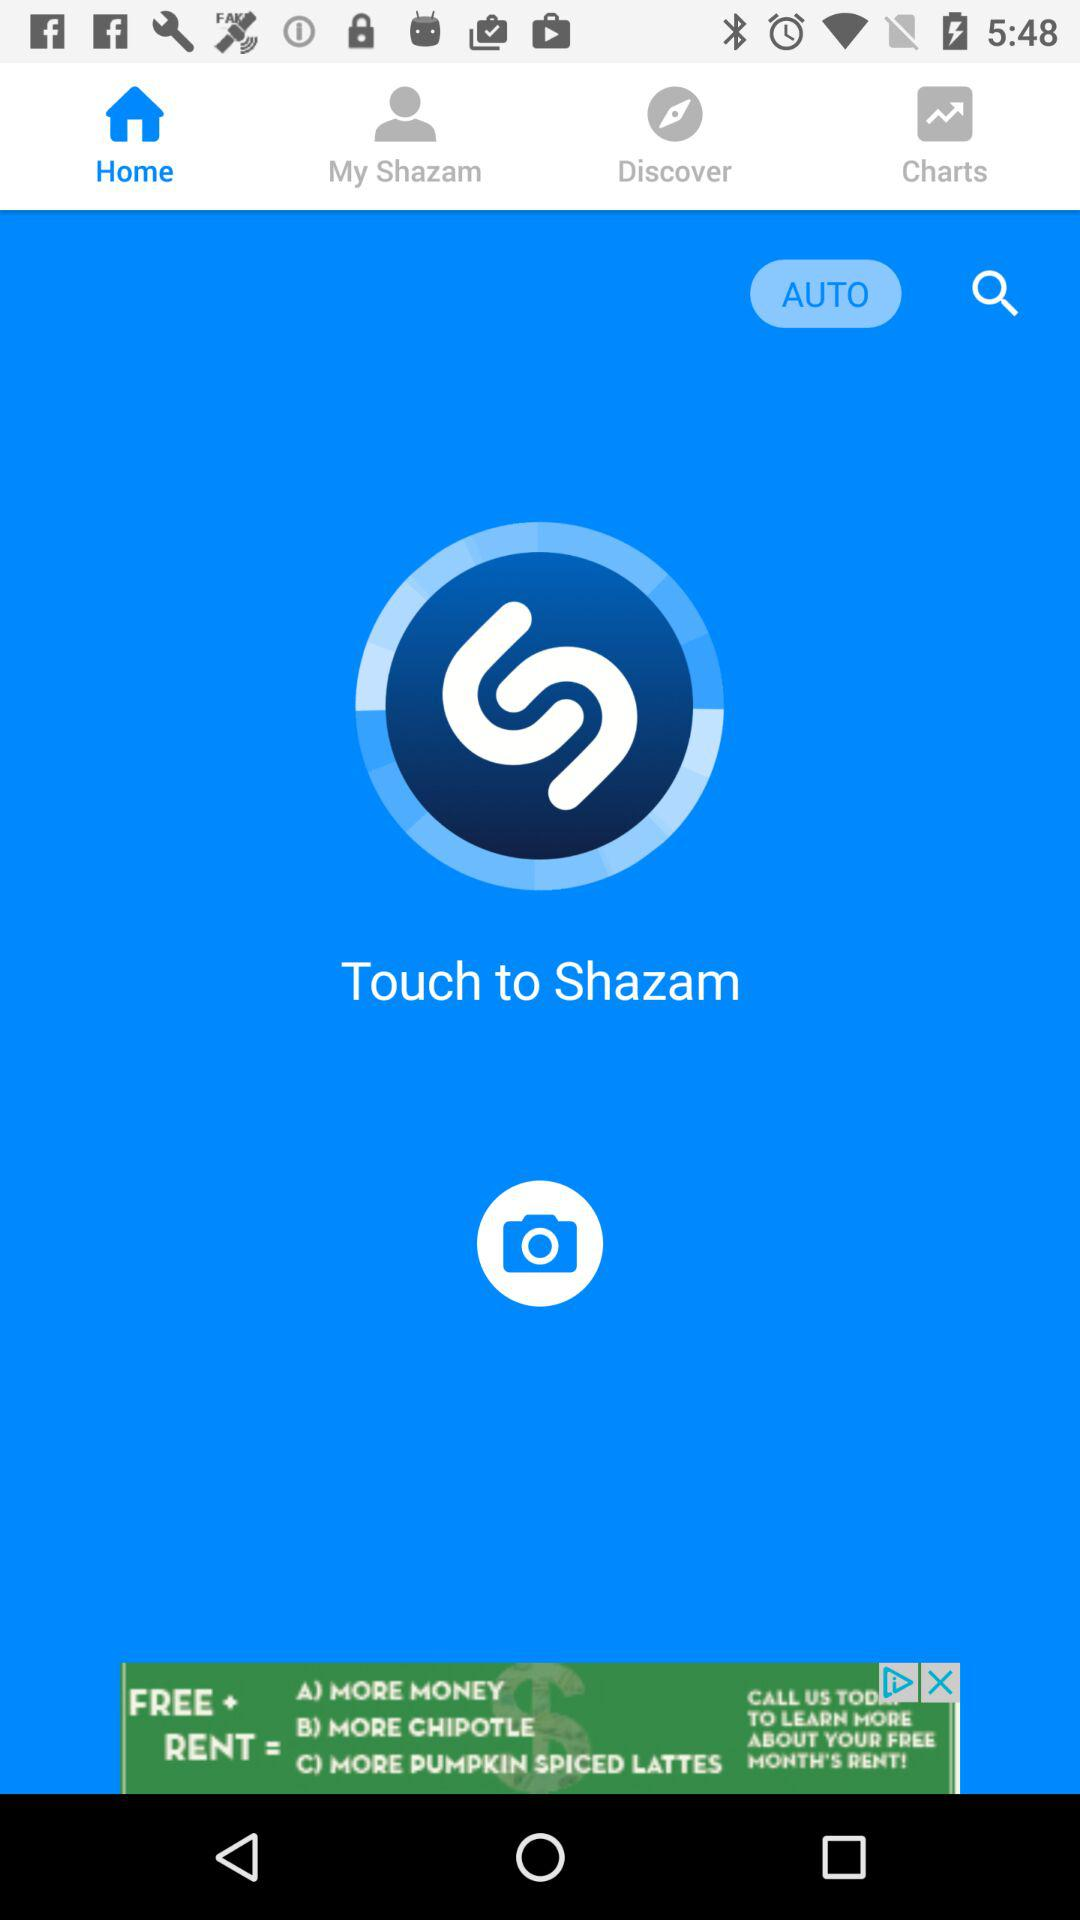Which tab has been selected? The tab that has been selected is "Home". 